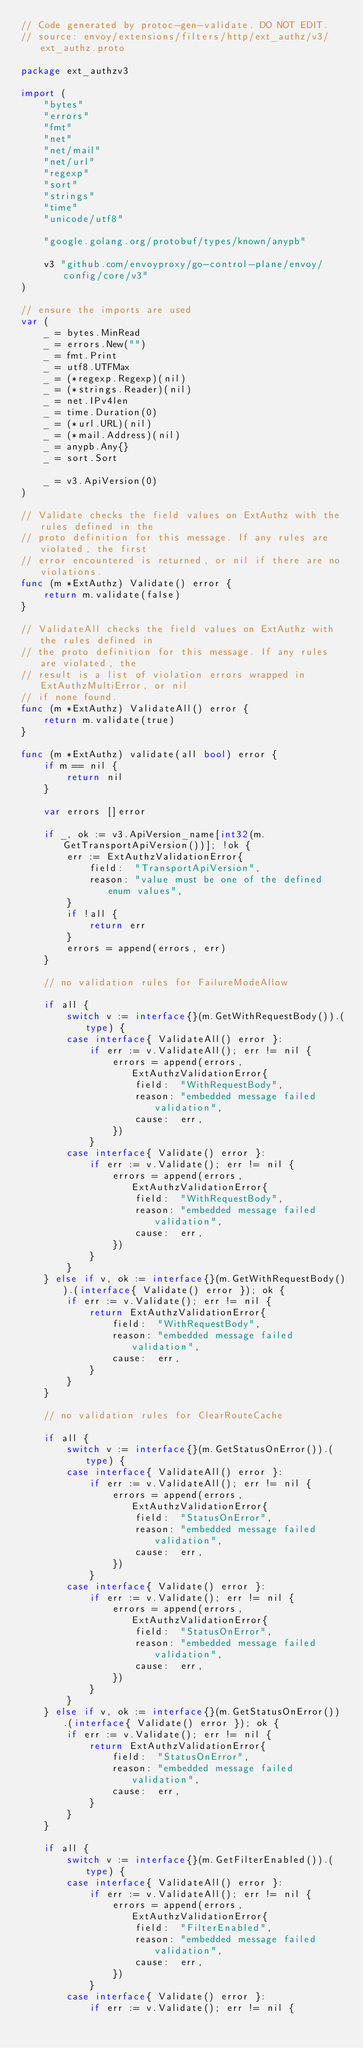Convert code to text. <code><loc_0><loc_0><loc_500><loc_500><_Go_>// Code generated by protoc-gen-validate. DO NOT EDIT.
// source: envoy/extensions/filters/http/ext_authz/v3/ext_authz.proto

package ext_authzv3

import (
	"bytes"
	"errors"
	"fmt"
	"net"
	"net/mail"
	"net/url"
	"regexp"
	"sort"
	"strings"
	"time"
	"unicode/utf8"

	"google.golang.org/protobuf/types/known/anypb"

	v3 "github.com/envoyproxy/go-control-plane/envoy/config/core/v3"
)

// ensure the imports are used
var (
	_ = bytes.MinRead
	_ = errors.New("")
	_ = fmt.Print
	_ = utf8.UTFMax
	_ = (*regexp.Regexp)(nil)
	_ = (*strings.Reader)(nil)
	_ = net.IPv4len
	_ = time.Duration(0)
	_ = (*url.URL)(nil)
	_ = (*mail.Address)(nil)
	_ = anypb.Any{}
	_ = sort.Sort

	_ = v3.ApiVersion(0)
)

// Validate checks the field values on ExtAuthz with the rules defined in the
// proto definition for this message. If any rules are violated, the first
// error encountered is returned, or nil if there are no violations.
func (m *ExtAuthz) Validate() error {
	return m.validate(false)
}

// ValidateAll checks the field values on ExtAuthz with the rules defined in
// the proto definition for this message. If any rules are violated, the
// result is a list of violation errors wrapped in ExtAuthzMultiError, or nil
// if none found.
func (m *ExtAuthz) ValidateAll() error {
	return m.validate(true)
}

func (m *ExtAuthz) validate(all bool) error {
	if m == nil {
		return nil
	}

	var errors []error

	if _, ok := v3.ApiVersion_name[int32(m.GetTransportApiVersion())]; !ok {
		err := ExtAuthzValidationError{
			field:  "TransportApiVersion",
			reason: "value must be one of the defined enum values",
		}
		if !all {
			return err
		}
		errors = append(errors, err)
	}

	// no validation rules for FailureModeAllow

	if all {
		switch v := interface{}(m.GetWithRequestBody()).(type) {
		case interface{ ValidateAll() error }:
			if err := v.ValidateAll(); err != nil {
				errors = append(errors, ExtAuthzValidationError{
					field:  "WithRequestBody",
					reason: "embedded message failed validation",
					cause:  err,
				})
			}
		case interface{ Validate() error }:
			if err := v.Validate(); err != nil {
				errors = append(errors, ExtAuthzValidationError{
					field:  "WithRequestBody",
					reason: "embedded message failed validation",
					cause:  err,
				})
			}
		}
	} else if v, ok := interface{}(m.GetWithRequestBody()).(interface{ Validate() error }); ok {
		if err := v.Validate(); err != nil {
			return ExtAuthzValidationError{
				field:  "WithRequestBody",
				reason: "embedded message failed validation",
				cause:  err,
			}
		}
	}

	// no validation rules for ClearRouteCache

	if all {
		switch v := interface{}(m.GetStatusOnError()).(type) {
		case interface{ ValidateAll() error }:
			if err := v.ValidateAll(); err != nil {
				errors = append(errors, ExtAuthzValidationError{
					field:  "StatusOnError",
					reason: "embedded message failed validation",
					cause:  err,
				})
			}
		case interface{ Validate() error }:
			if err := v.Validate(); err != nil {
				errors = append(errors, ExtAuthzValidationError{
					field:  "StatusOnError",
					reason: "embedded message failed validation",
					cause:  err,
				})
			}
		}
	} else if v, ok := interface{}(m.GetStatusOnError()).(interface{ Validate() error }); ok {
		if err := v.Validate(); err != nil {
			return ExtAuthzValidationError{
				field:  "StatusOnError",
				reason: "embedded message failed validation",
				cause:  err,
			}
		}
	}

	if all {
		switch v := interface{}(m.GetFilterEnabled()).(type) {
		case interface{ ValidateAll() error }:
			if err := v.ValidateAll(); err != nil {
				errors = append(errors, ExtAuthzValidationError{
					field:  "FilterEnabled",
					reason: "embedded message failed validation",
					cause:  err,
				})
			}
		case interface{ Validate() error }:
			if err := v.Validate(); err != nil {</code> 